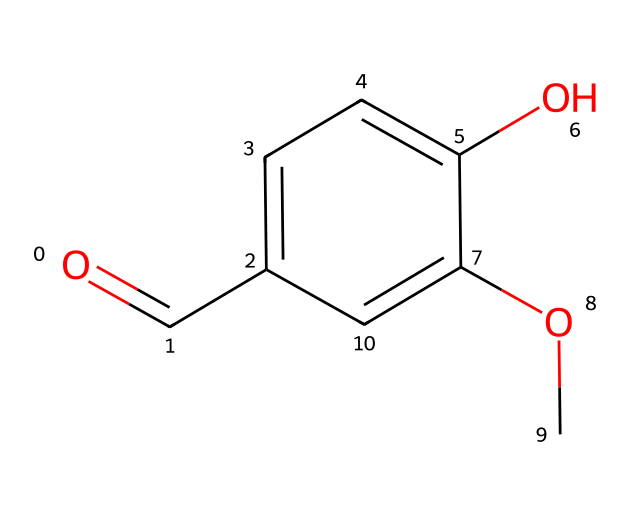What is the molecular formula of vanillin? The SMILES representation can be interpreted to count the number of each type of atom present. In this case, the structure contains 8 carbon atoms (C), 8 hydrogen atoms (H), and 3 oxygen atoms (O). Therefore, the molecular formula can be derived as C8H8O3.
Answer: C8H8O3 How many hydroxyl (–OH) groups are in the structure? By analyzing the structure, we can identify functional groups. There is one hydroxyl group (-OH) present in the structure, attached to the aromatic ring. This can be verified by locating the -OH functionality attached to a carbon atom in the benzene ring.
Answer: 1 What type of functional groups are present in vanillin? The structure features multiple functional groups. There is a benzene ring, a hydroxyl group (-OH), and an aldehyde group (-CHO) as evident from the carbonyl (C=O) in the depicted structure. Therefore, vanillin contains the hydroxyl and aldehyde functional groups.
Answer: hydroxyl and aldehyde What is the degree of unsaturation in vanillin? The degree of unsaturation can be calculated by considering the presence of double bonds and rings in the molecule. Each ring or double bond contributes one degree of unsaturation. Here, we have a benzene ring (which adds one degree) and a carbonyl double bond, resulting in a total of two degrees of unsaturation.
Answer: 2 Why is vanillin considered a flavoring agent? Vanillin contains a specific molecular structure that interacts with taste receptors, providing a distinctive vanilla flavor profile. The aromatic properties contributed by the benzene ring and functional groups enable it to be widely used for its flavor properties in food and beverages, particularly coffee.
Answer: flavor profile What characteristic of vanillin's structure contributes to its aroma? The presence of the aromatic benzene ring in vanillin is significant as it allows for the evaporation of the compound at room temperature, leading to a volatile compound that can easily release its aroma. This characteristic makes it effective as a fragrance in various applications.
Answer: aromatic benzene ring 